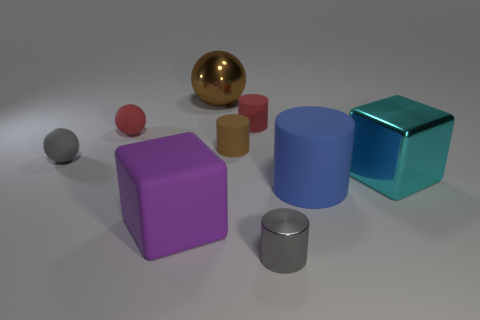There is a shiny object that is both on the left side of the blue cylinder and in front of the brown metallic thing; what shape is it?
Make the answer very short. Cylinder. Are there fewer large cyan metallic cubes in front of the purple cube than large purple rubber things?
Offer a very short reply. Yes. How many tiny objects are yellow metal objects or blue rubber cylinders?
Keep it short and to the point. 0. The metallic ball is what size?
Your response must be concise. Large. Is there anything else that has the same material as the small gray sphere?
Keep it short and to the point. Yes. There is a big rubber block; what number of tiny spheres are right of it?
Your response must be concise. 0. There is a purple matte object that is the same shape as the big cyan metal thing; what size is it?
Your response must be concise. Large. How big is the matte object that is both in front of the small gray rubber thing and to the right of the large purple rubber block?
Offer a very short reply. Large. Does the metallic cylinder have the same color as the large block that is in front of the blue rubber object?
Your answer should be compact. No. How many cyan objects are either large objects or small metallic things?
Provide a short and direct response. 1. 